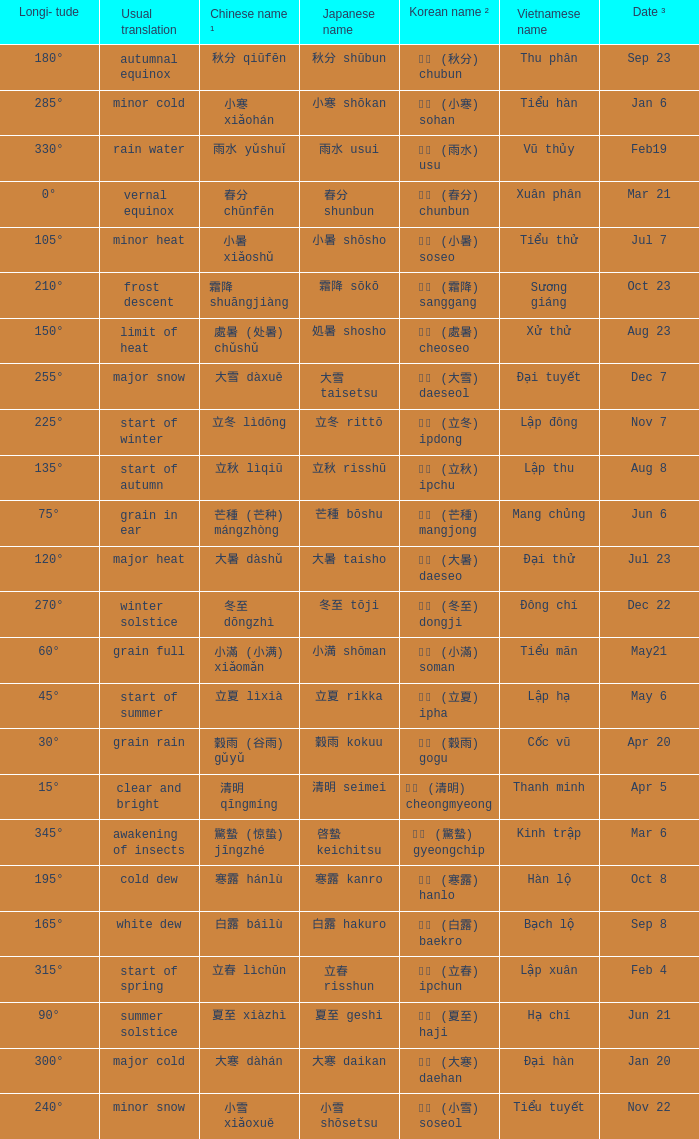Which Japanese name has a Korean name ² of 경칩 (驚蟄) gyeongchip? 啓蟄 keichitsu. 